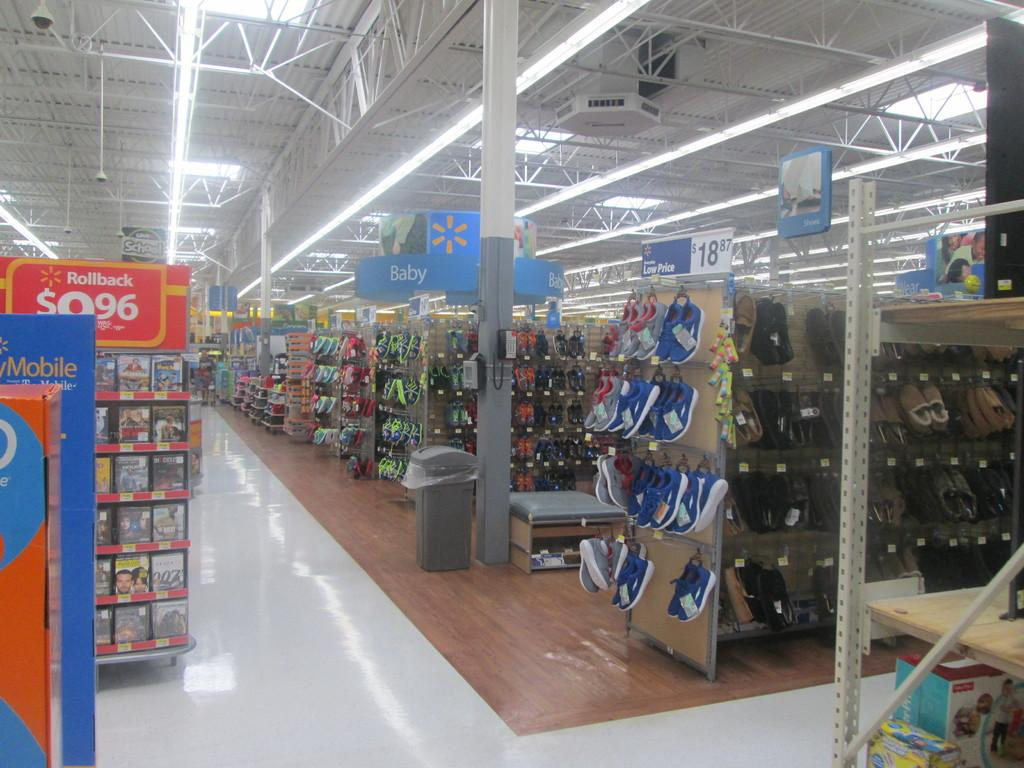<image>
Summarize the visual content of the image. Walmart store with empty aisles and a section for Rollback DVDs. 